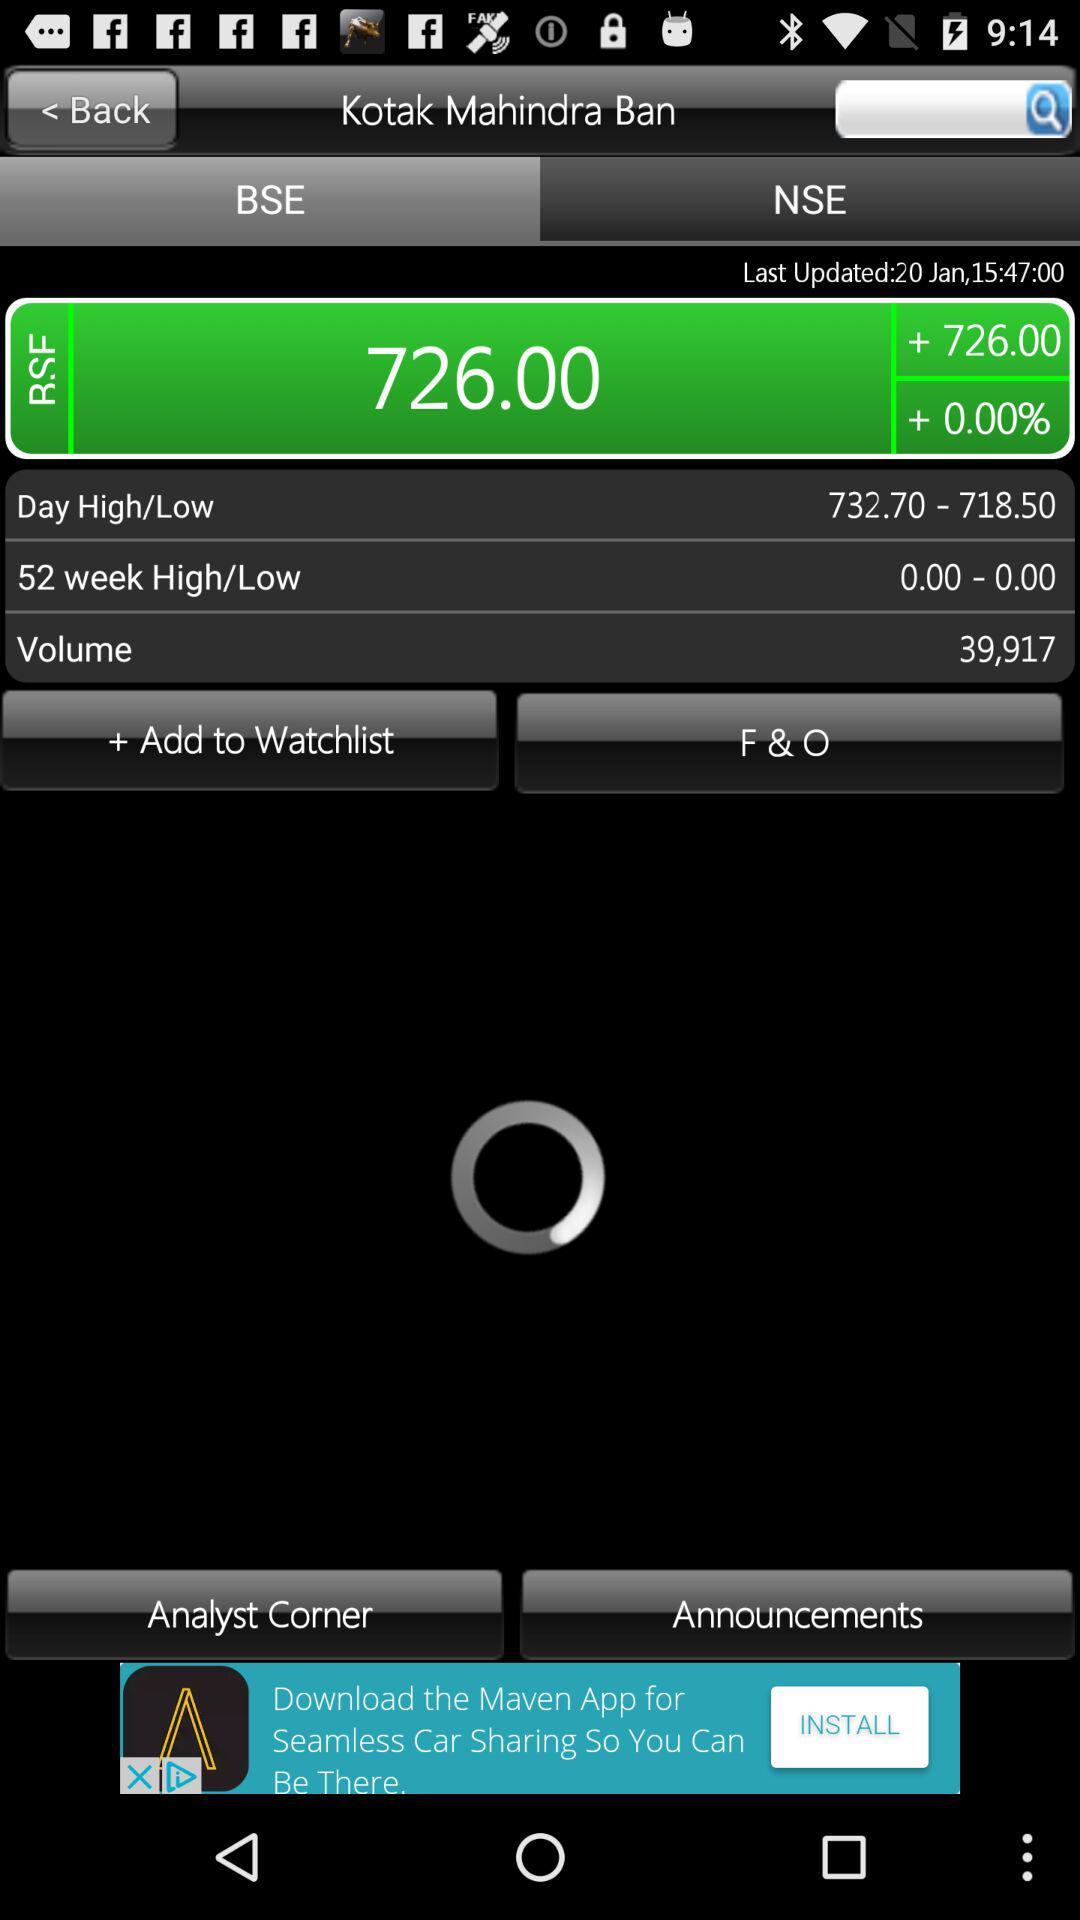When was it last updated? It was last updated on January 20 at 15:47:00. 